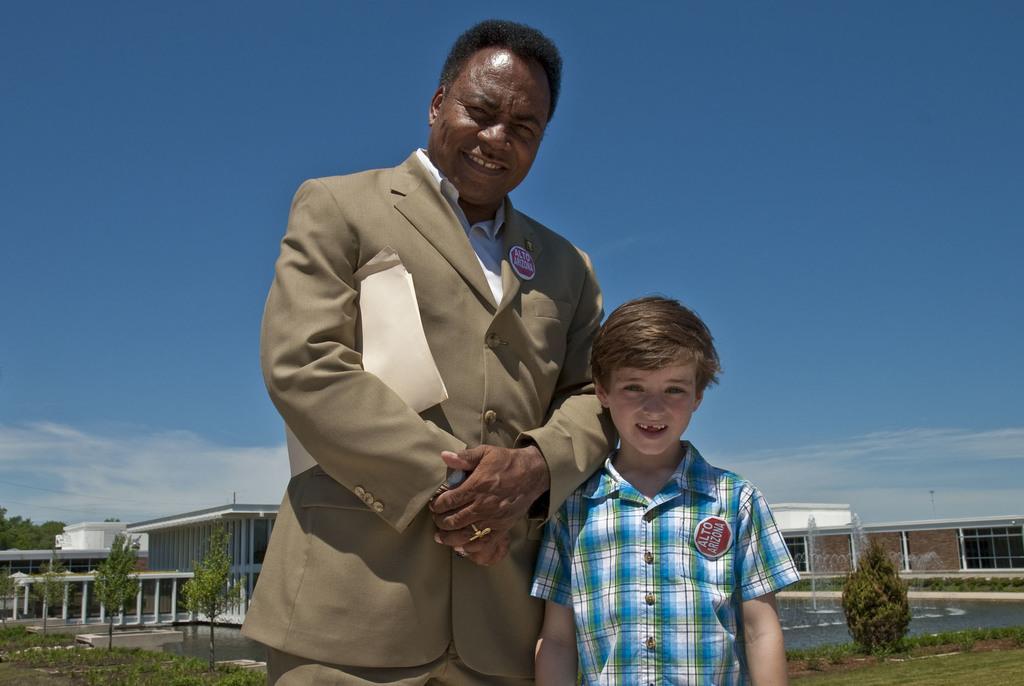Could you give a brief overview of what you see in this image? In the foreground of this image, there is a man holding few papers under the arm and beside him there is a boy. In the background, there is fountain, trees, grass, buildings, sky and the cloud. 